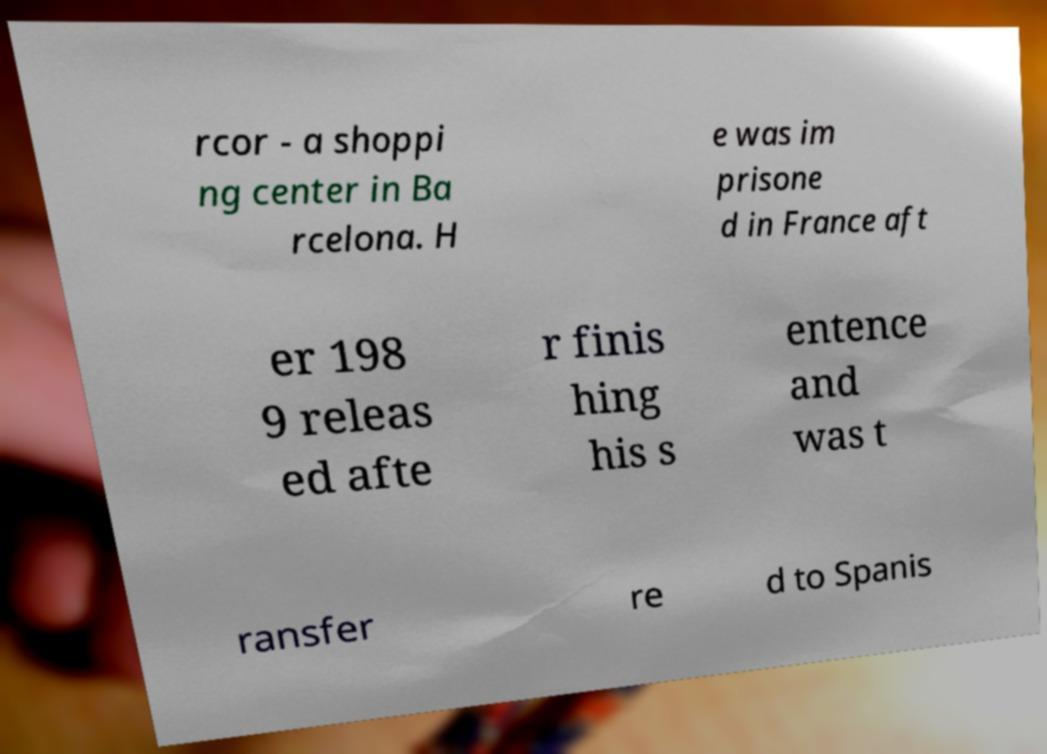Please identify and transcribe the text found in this image. rcor - a shoppi ng center in Ba rcelona. H e was im prisone d in France aft er 198 9 releas ed afte r finis hing his s entence and was t ransfer re d to Spanis 